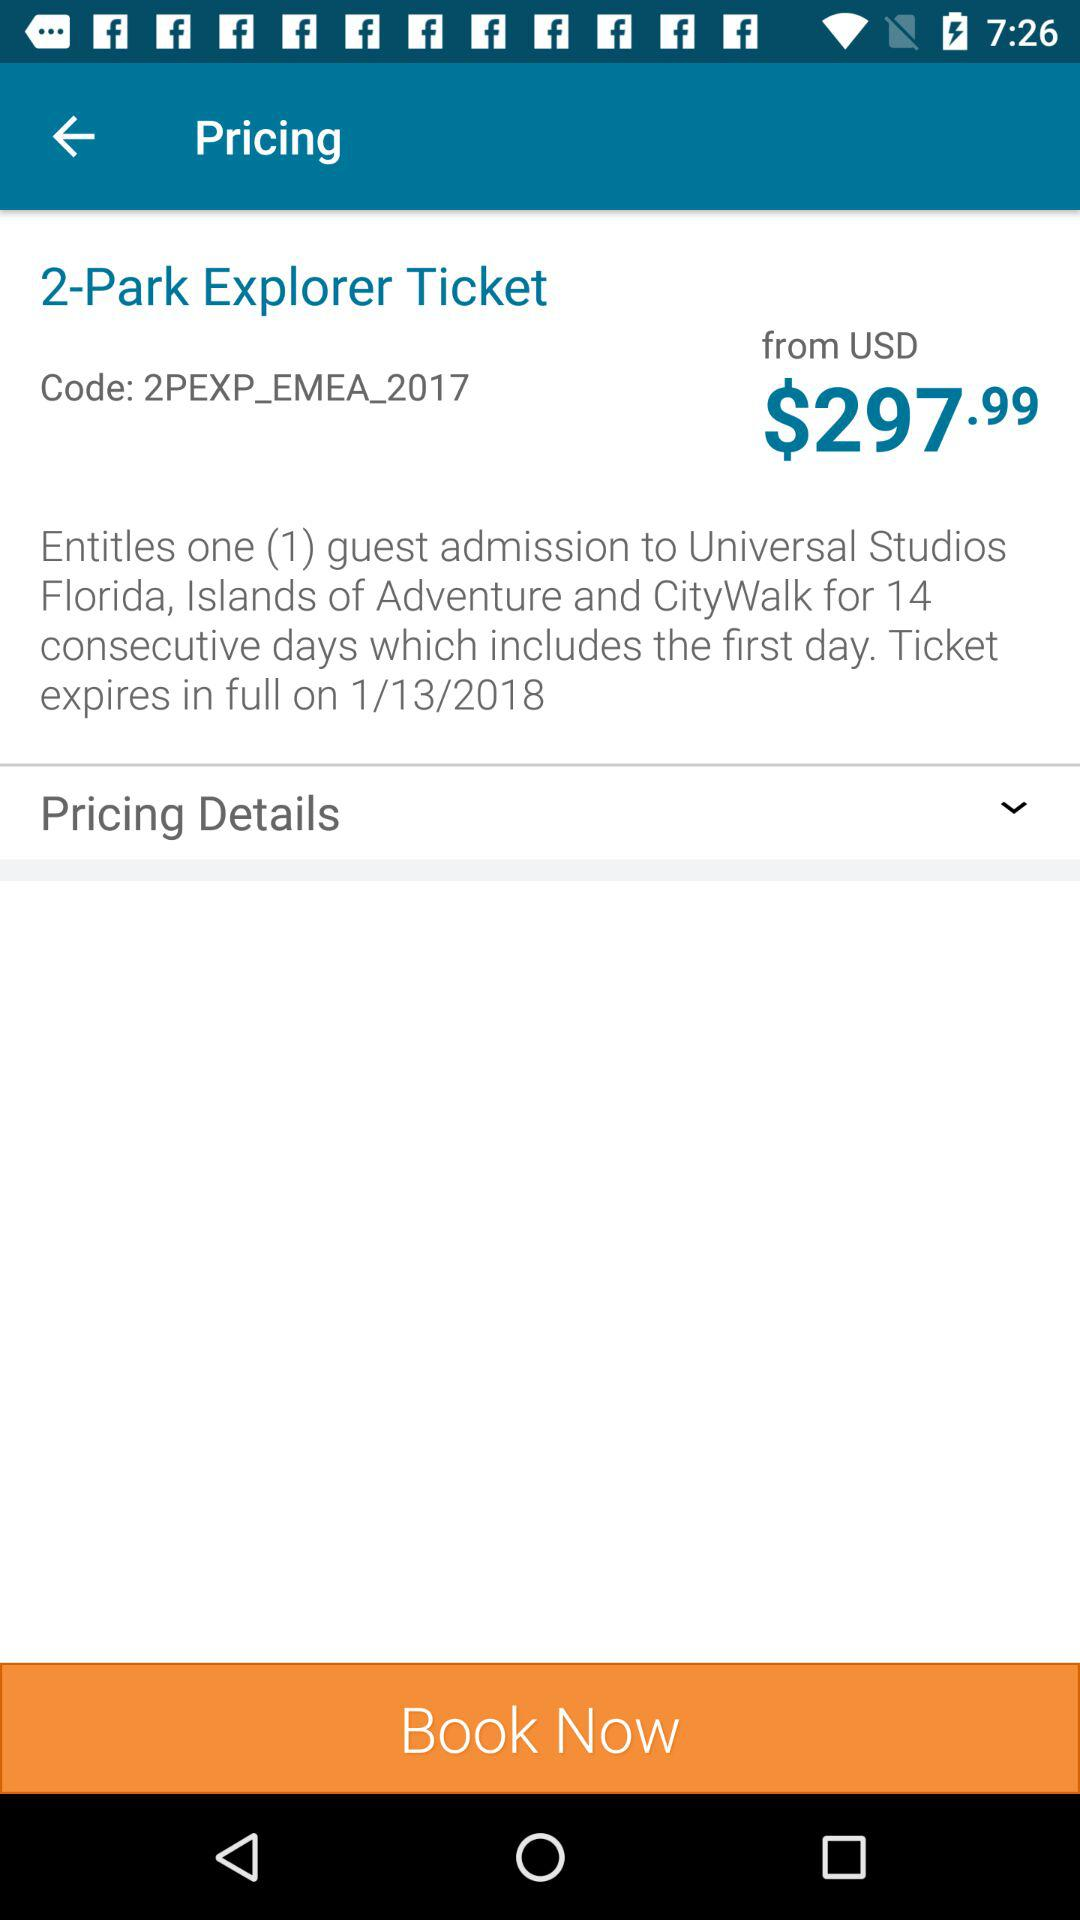For how many guests is the ticket booked? The ticket is booked for 1 guest. 